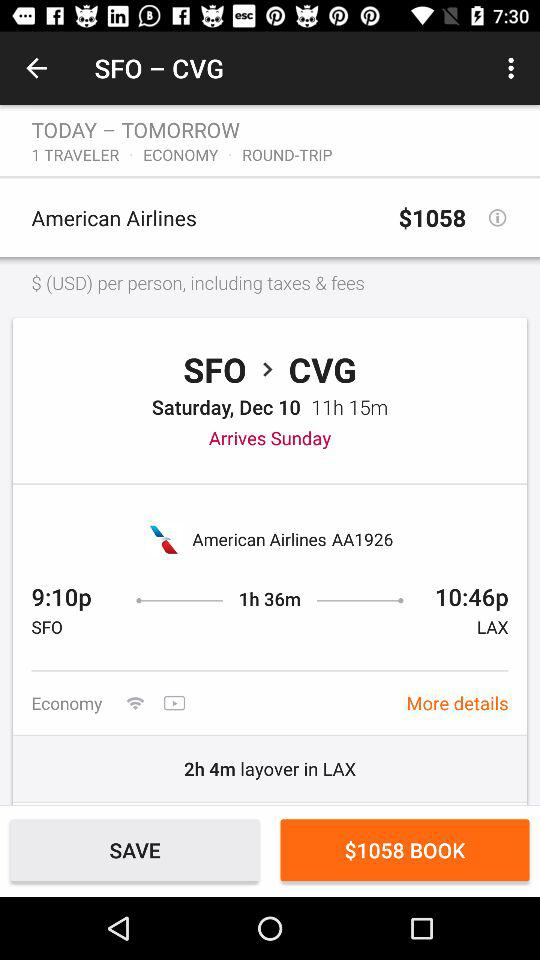What is the total number of travelers? The total number of travelers is 1. 